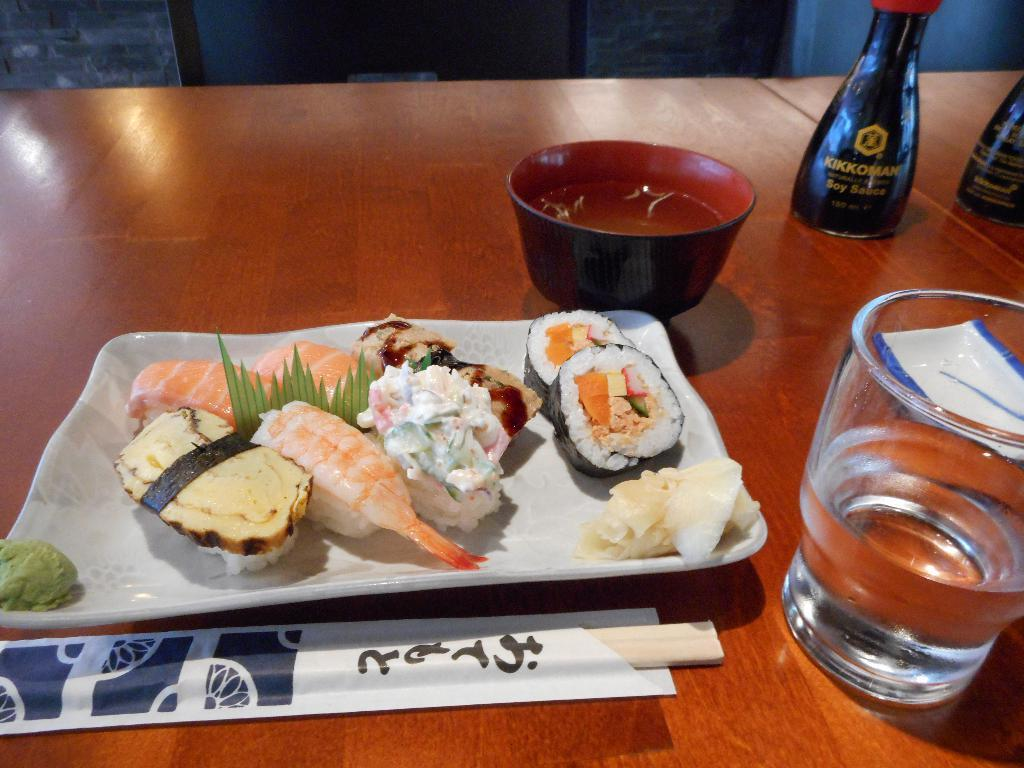What type of containers can be seen in the image? There are bottles and a glass with water in the image. What type of dish is present in the image? There is a bowl in the image. What is the purpose of the tray in the image? The tray is likely used for holding and organizing items on the table. What type of food items are visible in the image? There are food items in the image. What other objects can be seen on the table in the image? There are other objects on the table in the image. What can be seen in the background of the image? There is a stand in the background of the image. How many fingers are visible on the mice in the image? There are no mice present in the image, and therefore no fingers can be seen on them. 